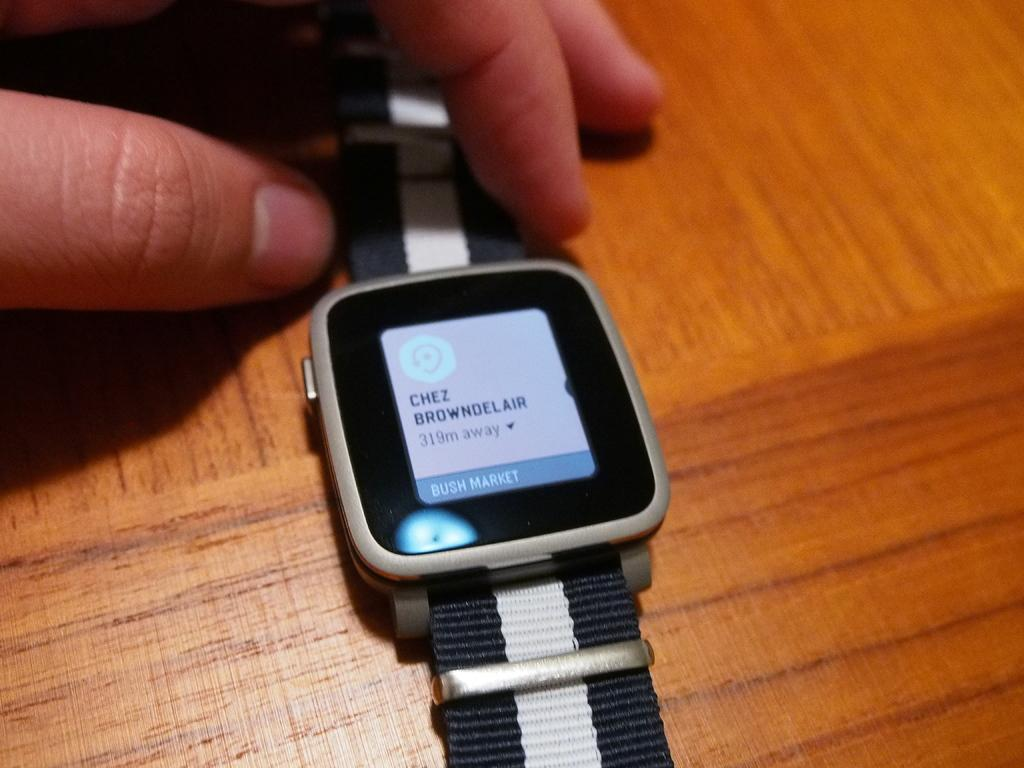<image>
Render a clear and concise summary of the photo. A watch with the name Chez Browndelair on the home screen. 